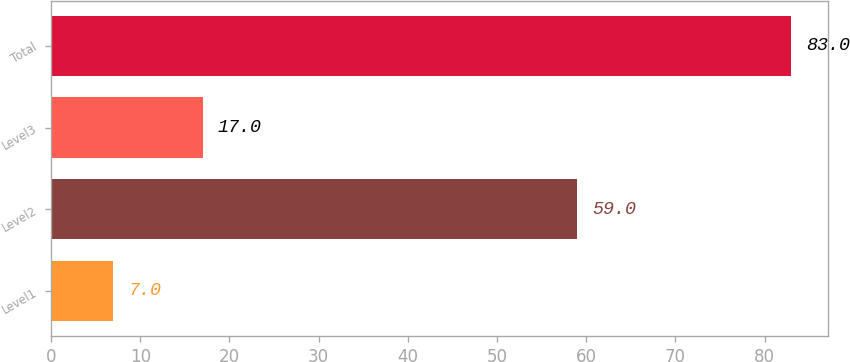Convert chart to OTSL. <chart><loc_0><loc_0><loc_500><loc_500><bar_chart><fcel>Level1<fcel>Level2<fcel>Level3<fcel>Total<nl><fcel>7<fcel>59<fcel>17<fcel>83<nl></chart> 